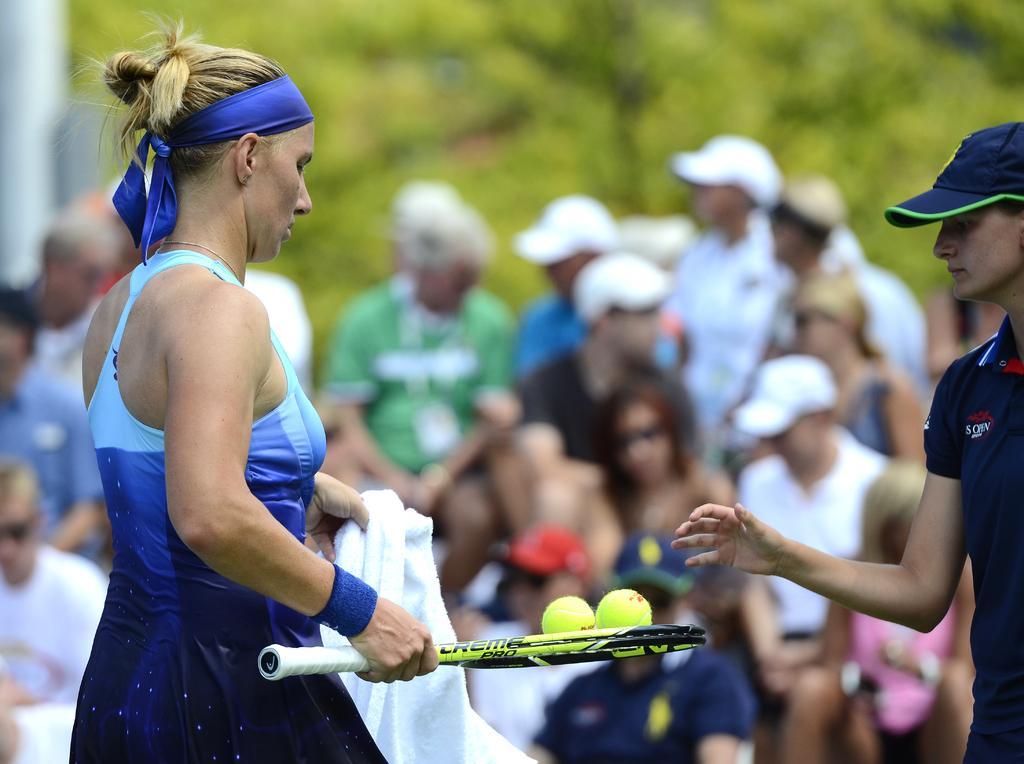Could you give a brief overview of what you see in this image? This picture shows a woman holding a tennis racket with two balls in her hand and we see other woman standing and we see few people seated on the side and we see a tree on their back 